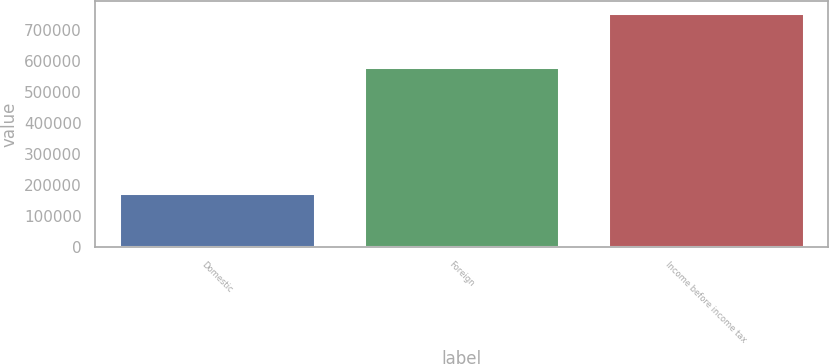<chart> <loc_0><loc_0><loc_500><loc_500><bar_chart><fcel>Domestic<fcel>Foreign<fcel>Income before income tax<nl><fcel>173865<fcel>580971<fcel>754836<nl></chart> 